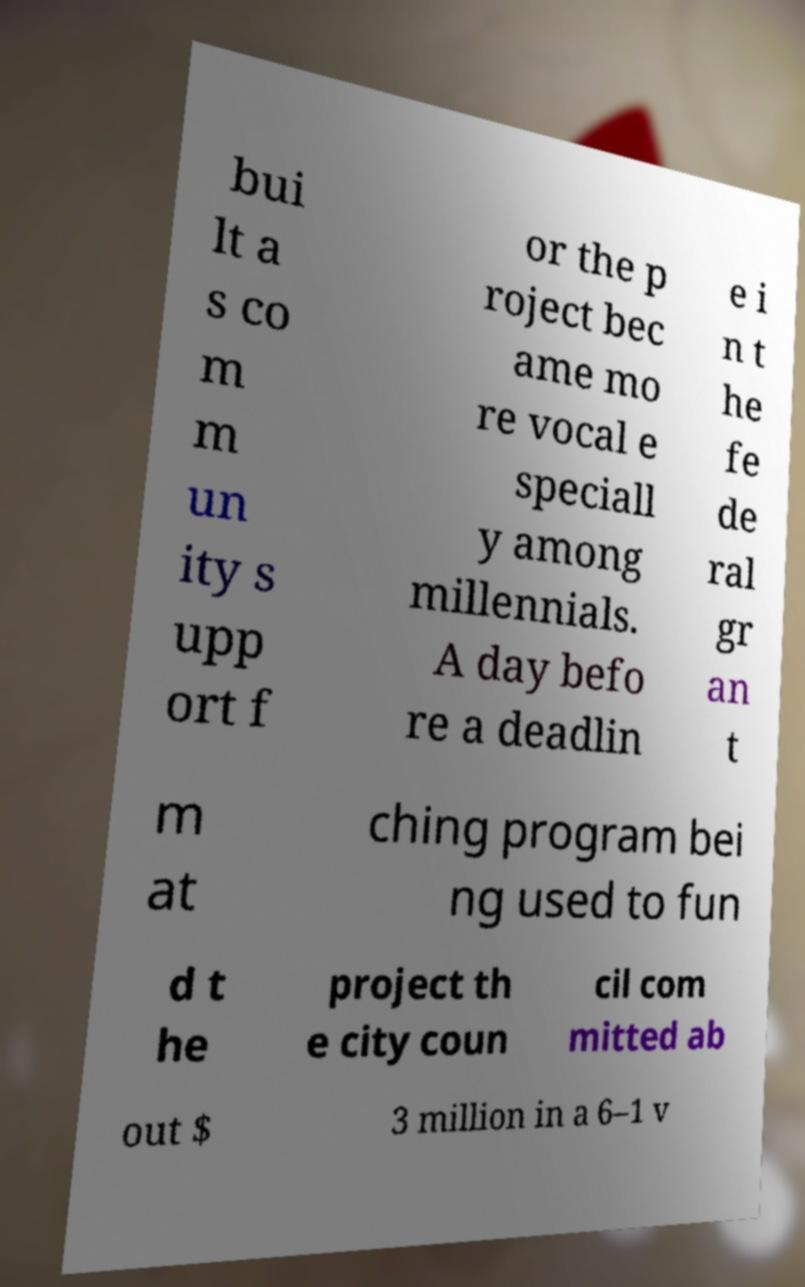Can you read and provide the text displayed in the image?This photo seems to have some interesting text. Can you extract and type it out for me? bui lt a s co m m un ity s upp ort f or the p roject bec ame mo re vocal e speciall y among millennials. A day befo re a deadlin e i n t he fe de ral gr an t m at ching program bei ng used to fun d t he project th e city coun cil com mitted ab out $ 3 million in a 6–1 v 